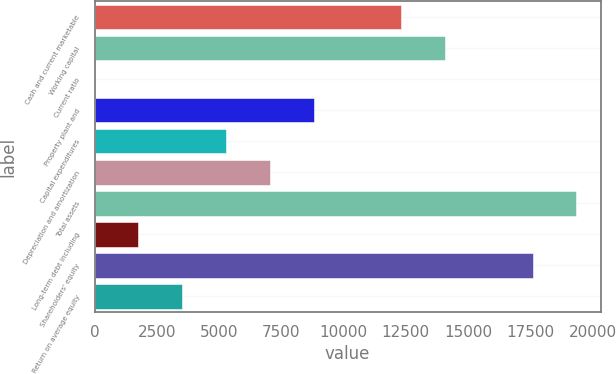Convert chart to OTSL. <chart><loc_0><loc_0><loc_500><loc_500><bar_chart><fcel>Cash and current marketable<fcel>Working capital<fcel>Current ratio<fcel>Property plant and<fcel>Capital expenditures<fcel>Depreciation and amortization<fcel>Total assets<fcel>Long-term debt including<fcel>Shareholders' equity<fcel>Return on average equity<nl><fcel>12316.8<fcel>14075.9<fcel>3.4<fcel>8798.7<fcel>5280.58<fcel>7039.64<fcel>19353.1<fcel>1762.46<fcel>17594<fcel>3521.52<nl></chart> 